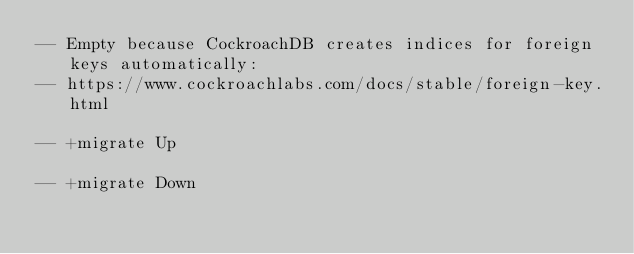<code> <loc_0><loc_0><loc_500><loc_500><_SQL_>-- Empty because CockroachDB creates indices for foreign keys automatically:
-- https://www.cockroachlabs.com/docs/stable/foreign-key.html

-- +migrate Up

-- +migrate Down
</code> 